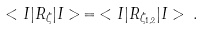Convert formula to latex. <formula><loc_0><loc_0><loc_500><loc_500>< I | R _ { \zeta } | I > \, = \, < I | R _ { \zeta _ { 1 , 2 } } | I > \, .</formula> 